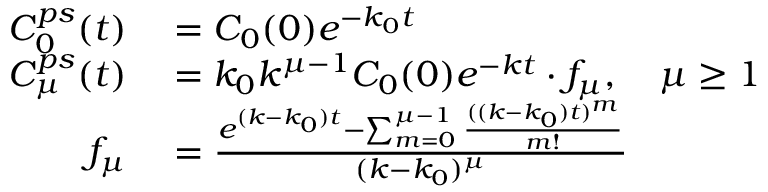Convert formula to latex. <formula><loc_0><loc_0><loc_500><loc_500>\begin{array} { r l } { C _ { 0 } ^ { p s } ( t ) } & = C _ { 0 } ( 0 ) e ^ { - k _ { 0 } t } } \\ { C _ { \mu } ^ { p s } ( t ) } & = k _ { 0 } k ^ { \mu - 1 } C _ { 0 } ( 0 ) e ^ { - k t } \cdot f _ { \mu } , \quad \mu \geq 1 } \\ { f _ { \mu } } & = \frac { e ^ { ( k - k _ { 0 } ) t } - \sum _ { m = 0 } ^ { \mu - 1 } \frac { ( ( k - k _ { 0 } ) t ) ^ { m } } { m ! } } { ( k - k _ { 0 } ) ^ { \mu } } } \end{array}</formula> 